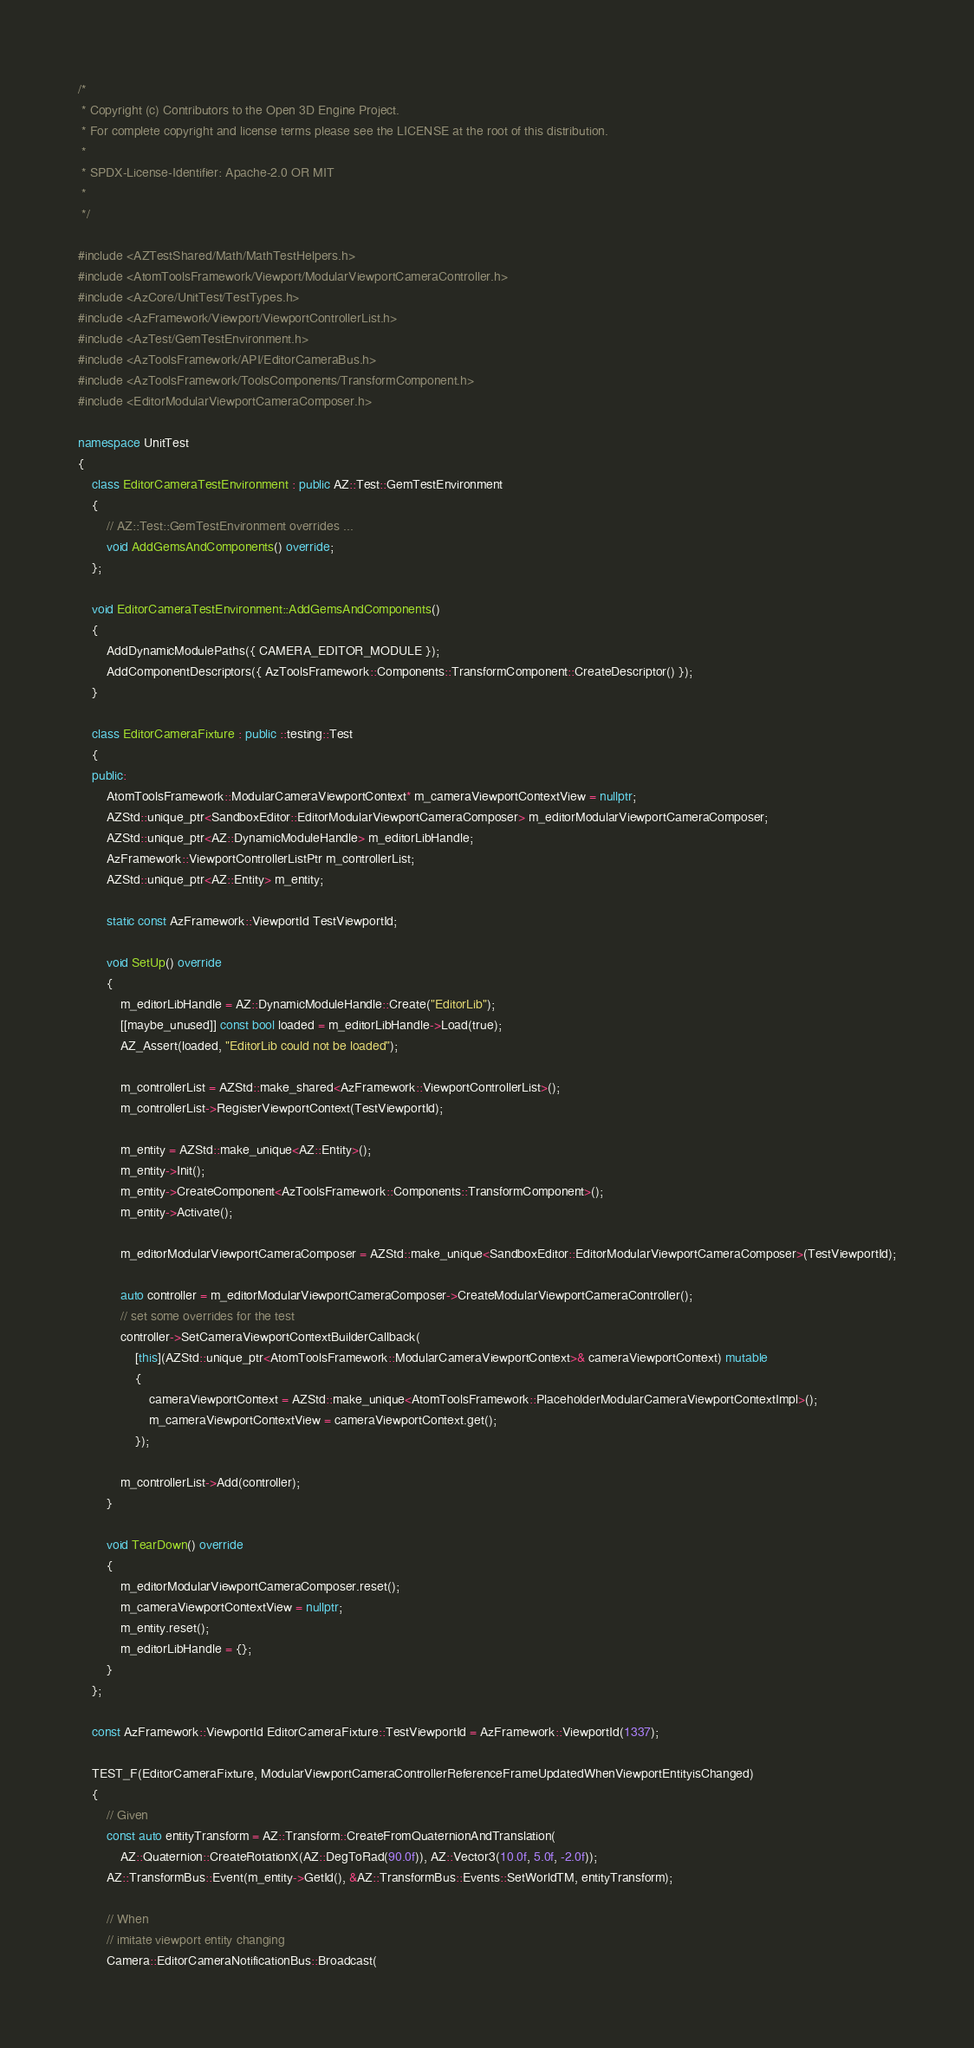Convert code to text. <code><loc_0><loc_0><loc_500><loc_500><_C++_>/*
 * Copyright (c) Contributors to the Open 3D Engine Project.
 * For complete copyright and license terms please see the LICENSE at the root of this distribution.
 *
 * SPDX-License-Identifier: Apache-2.0 OR MIT
 *
 */

#include <AZTestShared/Math/MathTestHelpers.h>
#include <AtomToolsFramework/Viewport/ModularViewportCameraController.h>
#include <AzCore/UnitTest/TestTypes.h>
#include <AzFramework/Viewport/ViewportControllerList.h>
#include <AzTest/GemTestEnvironment.h>
#include <AzToolsFramework/API/EditorCameraBus.h>
#include <AzToolsFramework/ToolsComponents/TransformComponent.h>
#include <EditorModularViewportCameraComposer.h>

namespace UnitTest
{
    class EditorCameraTestEnvironment : public AZ::Test::GemTestEnvironment
    {
        // AZ::Test::GemTestEnvironment overrides ...
        void AddGemsAndComponents() override;
    };

    void EditorCameraTestEnvironment::AddGemsAndComponents()
    {
        AddDynamicModulePaths({ CAMERA_EDITOR_MODULE });
        AddComponentDescriptors({ AzToolsFramework::Components::TransformComponent::CreateDescriptor() });
    }

    class EditorCameraFixture : public ::testing::Test
    {
    public:
        AtomToolsFramework::ModularCameraViewportContext* m_cameraViewportContextView = nullptr;
        AZStd::unique_ptr<SandboxEditor::EditorModularViewportCameraComposer> m_editorModularViewportCameraComposer;
        AZStd::unique_ptr<AZ::DynamicModuleHandle> m_editorLibHandle;
        AzFramework::ViewportControllerListPtr m_controllerList;
        AZStd::unique_ptr<AZ::Entity> m_entity;

        static const AzFramework::ViewportId TestViewportId;

        void SetUp() override
        {
            m_editorLibHandle = AZ::DynamicModuleHandle::Create("EditorLib");
            [[maybe_unused]] const bool loaded = m_editorLibHandle->Load(true);
            AZ_Assert(loaded, "EditorLib could not be loaded");

            m_controllerList = AZStd::make_shared<AzFramework::ViewportControllerList>();
            m_controllerList->RegisterViewportContext(TestViewportId);

            m_entity = AZStd::make_unique<AZ::Entity>();
            m_entity->Init();
            m_entity->CreateComponent<AzToolsFramework::Components::TransformComponent>();
            m_entity->Activate();

            m_editorModularViewportCameraComposer = AZStd::make_unique<SandboxEditor::EditorModularViewportCameraComposer>(TestViewportId);

            auto controller = m_editorModularViewportCameraComposer->CreateModularViewportCameraController();
            // set some overrides for the test
            controller->SetCameraViewportContextBuilderCallback(
                [this](AZStd::unique_ptr<AtomToolsFramework::ModularCameraViewportContext>& cameraViewportContext) mutable
                {
                    cameraViewportContext = AZStd::make_unique<AtomToolsFramework::PlaceholderModularCameraViewportContextImpl>();
                    m_cameraViewportContextView = cameraViewportContext.get();
                });

            m_controllerList->Add(controller);
        }

        void TearDown() override
        {
            m_editorModularViewportCameraComposer.reset();
            m_cameraViewportContextView = nullptr;
            m_entity.reset();
            m_editorLibHandle = {};
        }
    };

    const AzFramework::ViewportId EditorCameraFixture::TestViewportId = AzFramework::ViewportId(1337);

    TEST_F(EditorCameraFixture, ModularViewportCameraControllerReferenceFrameUpdatedWhenViewportEntityisChanged)
    {
        // Given
        const auto entityTransform = AZ::Transform::CreateFromQuaternionAndTranslation(
            AZ::Quaternion::CreateRotationX(AZ::DegToRad(90.0f)), AZ::Vector3(10.0f, 5.0f, -2.0f));
        AZ::TransformBus::Event(m_entity->GetId(), &AZ::TransformBus::Events::SetWorldTM, entityTransform);

        // When
        // imitate viewport entity changing
        Camera::EditorCameraNotificationBus::Broadcast(</code> 